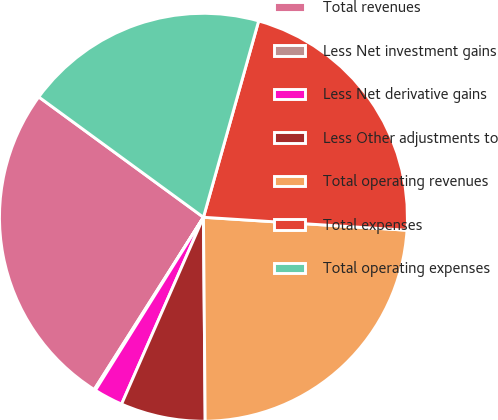Convert chart. <chart><loc_0><loc_0><loc_500><loc_500><pie_chart><fcel>Total revenues<fcel>Less Net investment gains<fcel>Less Net derivative gains<fcel>Less Other adjustments to<fcel>Total operating revenues<fcel>Total expenses<fcel>Total operating expenses<nl><fcel>26.05%<fcel>0.11%<fcel>2.31%<fcel>6.71%<fcel>23.85%<fcel>21.65%<fcel>19.32%<nl></chart> 